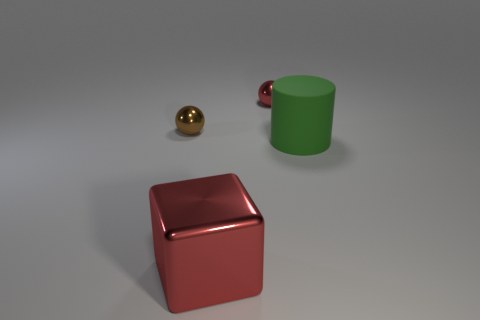Add 3 large green blocks. How many objects exist? 7 Subtract all cubes. How many objects are left? 3 Subtract all big blocks. Subtract all red blocks. How many objects are left? 2 Add 2 tiny brown shiny balls. How many tiny brown shiny balls are left? 3 Add 4 red metal spheres. How many red metal spheres exist? 5 Subtract 0 green cubes. How many objects are left? 4 